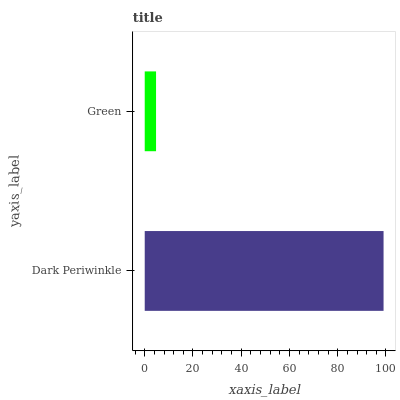Is Green the minimum?
Answer yes or no. Yes. Is Dark Periwinkle the maximum?
Answer yes or no. Yes. Is Green the maximum?
Answer yes or no. No. Is Dark Periwinkle greater than Green?
Answer yes or no. Yes. Is Green less than Dark Periwinkle?
Answer yes or no. Yes. Is Green greater than Dark Periwinkle?
Answer yes or no. No. Is Dark Periwinkle less than Green?
Answer yes or no. No. Is Dark Periwinkle the high median?
Answer yes or no. Yes. Is Green the low median?
Answer yes or no. Yes. Is Green the high median?
Answer yes or no. No. Is Dark Periwinkle the low median?
Answer yes or no. No. 